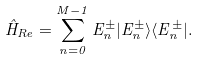<formula> <loc_0><loc_0><loc_500><loc_500>\hat { H } _ { R e } = \sum _ { n = 0 } ^ { M - 1 } E _ { n } ^ { \pm } | E _ { n } ^ { \pm } \rangle \langle E _ { n } ^ { \pm } | .</formula> 